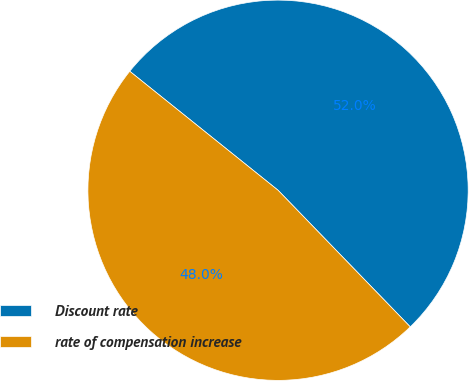<chart> <loc_0><loc_0><loc_500><loc_500><pie_chart><fcel>Discount rate<fcel>rate of compensation increase<nl><fcel>52.0%<fcel>48.0%<nl></chart> 